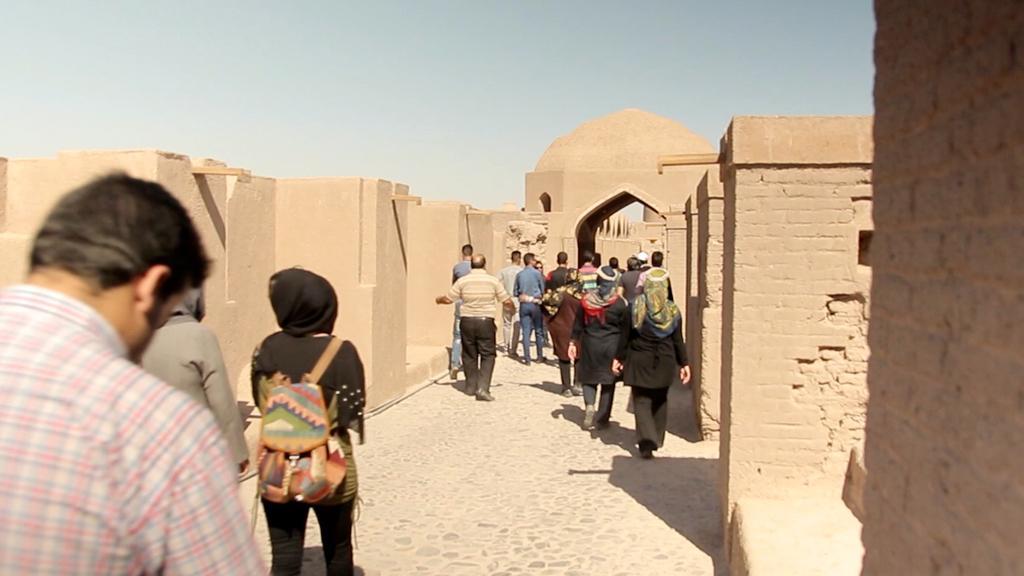Please provide a concise description of this image. In this picture I can see group of people standing, there is a fort, and in the background there is sky. 